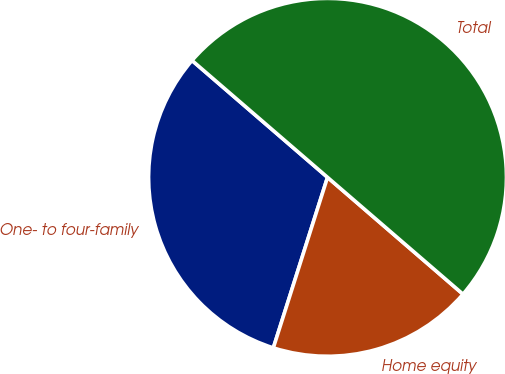<chart> <loc_0><loc_0><loc_500><loc_500><pie_chart><fcel>One- to four-family<fcel>Home equity<fcel>Total<nl><fcel>31.43%<fcel>18.57%<fcel>50.0%<nl></chart> 